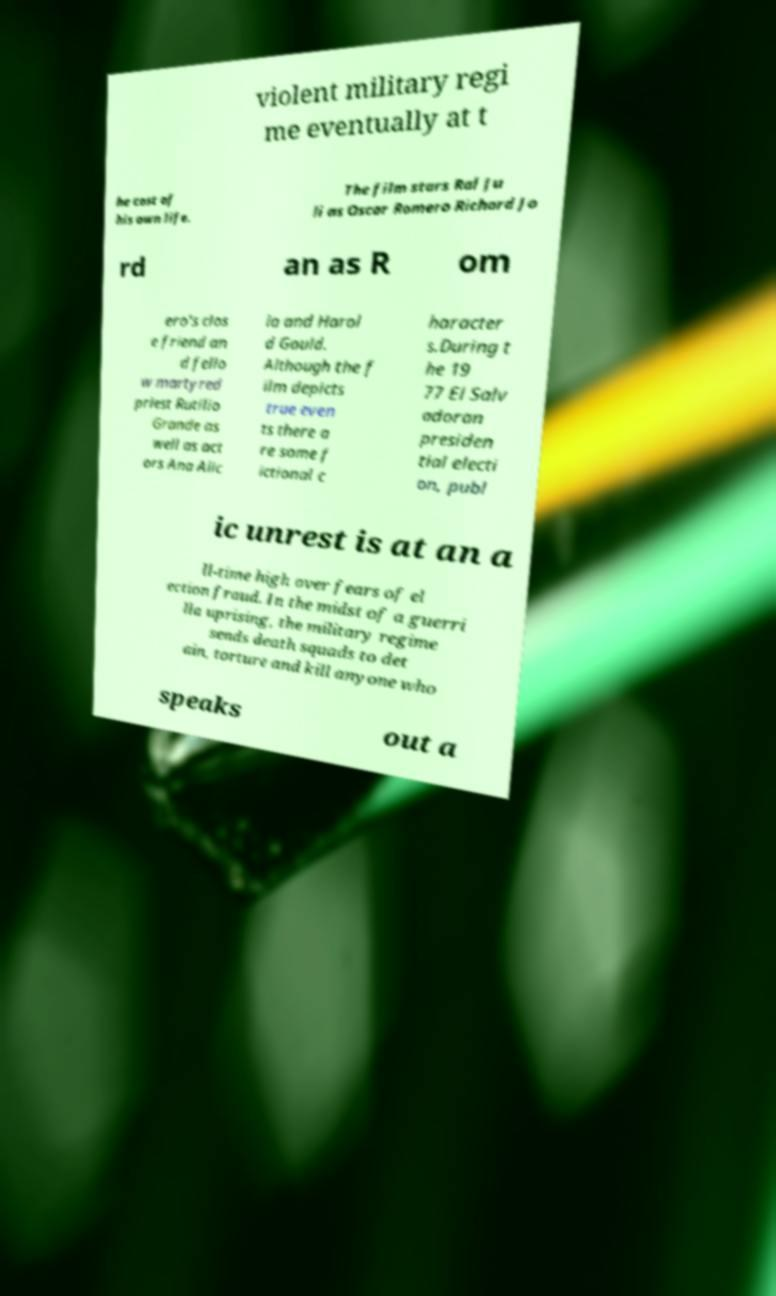Please identify and transcribe the text found in this image. violent military regi me eventually at t he cost of his own life. The film stars Ral Ju li as Oscar Romero Richard Jo rd an as R om ero's clos e friend an d fello w martyred priest Rutilio Grande as well as act ors Ana Alic ia and Harol d Gould. Although the f ilm depicts true even ts there a re some f ictional c haracter s.During t he 19 77 El Salv adoran presiden tial electi on, publ ic unrest is at an a ll-time high over fears of el ection fraud. In the midst of a guerri lla uprising, the military regime sends death squads to det ain, torture and kill anyone who speaks out a 